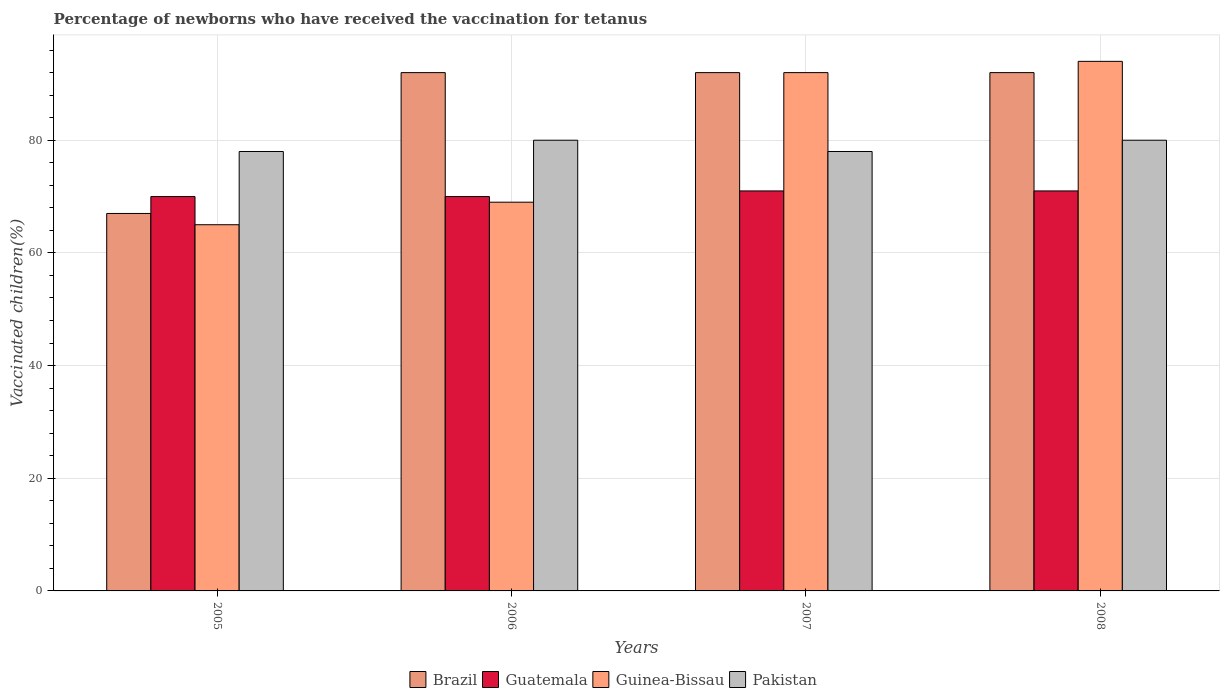How many different coloured bars are there?
Keep it short and to the point. 4. Are the number of bars on each tick of the X-axis equal?
Make the answer very short. Yes. How many bars are there on the 1st tick from the left?
Keep it short and to the point. 4. How many bars are there on the 2nd tick from the right?
Offer a terse response. 4. What is the percentage of vaccinated children in Guatemala in 2006?
Provide a succinct answer. 70. Across all years, what is the maximum percentage of vaccinated children in Guatemala?
Provide a succinct answer. 71. In which year was the percentage of vaccinated children in Guatemala maximum?
Provide a succinct answer. 2007. What is the total percentage of vaccinated children in Guatemala in the graph?
Provide a short and direct response. 282. What is the difference between the percentage of vaccinated children in Pakistan in 2005 and that in 2007?
Offer a terse response. 0. What is the average percentage of vaccinated children in Guinea-Bissau per year?
Keep it short and to the point. 80. What is the ratio of the percentage of vaccinated children in Guatemala in 2006 to that in 2008?
Your response must be concise. 0.99. Is the percentage of vaccinated children in Brazil in 2006 less than that in 2007?
Give a very brief answer. No. What is the difference between the highest and the second highest percentage of vaccinated children in Brazil?
Provide a succinct answer. 0. In how many years, is the percentage of vaccinated children in Guinea-Bissau greater than the average percentage of vaccinated children in Guinea-Bissau taken over all years?
Your response must be concise. 2. Is the sum of the percentage of vaccinated children in Pakistan in 2007 and 2008 greater than the maximum percentage of vaccinated children in Guinea-Bissau across all years?
Your response must be concise. Yes. Is it the case that in every year, the sum of the percentage of vaccinated children in Guinea-Bissau and percentage of vaccinated children in Guatemala is greater than the sum of percentage of vaccinated children in Brazil and percentage of vaccinated children in Pakistan?
Your answer should be compact. No. What does the 1st bar from the right in 2007 represents?
Offer a terse response. Pakistan. How many bars are there?
Your answer should be very brief. 16. How many years are there in the graph?
Offer a very short reply. 4. Does the graph contain any zero values?
Provide a succinct answer. No. Does the graph contain grids?
Provide a short and direct response. Yes. Where does the legend appear in the graph?
Offer a very short reply. Bottom center. How many legend labels are there?
Give a very brief answer. 4. What is the title of the graph?
Your answer should be compact. Percentage of newborns who have received the vaccination for tetanus. What is the label or title of the X-axis?
Your answer should be compact. Years. What is the label or title of the Y-axis?
Make the answer very short. Vaccinated children(%). What is the Vaccinated children(%) of Brazil in 2005?
Offer a very short reply. 67. What is the Vaccinated children(%) of Guinea-Bissau in 2005?
Your answer should be compact. 65. What is the Vaccinated children(%) in Brazil in 2006?
Provide a short and direct response. 92. What is the Vaccinated children(%) of Guinea-Bissau in 2006?
Ensure brevity in your answer.  69. What is the Vaccinated children(%) of Pakistan in 2006?
Your answer should be very brief. 80. What is the Vaccinated children(%) of Brazil in 2007?
Offer a very short reply. 92. What is the Vaccinated children(%) of Guinea-Bissau in 2007?
Provide a short and direct response. 92. What is the Vaccinated children(%) of Brazil in 2008?
Provide a succinct answer. 92. What is the Vaccinated children(%) of Guinea-Bissau in 2008?
Keep it short and to the point. 94. Across all years, what is the maximum Vaccinated children(%) in Brazil?
Offer a very short reply. 92. Across all years, what is the maximum Vaccinated children(%) of Guatemala?
Make the answer very short. 71. Across all years, what is the maximum Vaccinated children(%) in Guinea-Bissau?
Your answer should be compact. 94. Across all years, what is the maximum Vaccinated children(%) of Pakistan?
Make the answer very short. 80. Across all years, what is the minimum Vaccinated children(%) in Brazil?
Make the answer very short. 67. Across all years, what is the minimum Vaccinated children(%) of Guatemala?
Offer a very short reply. 70. What is the total Vaccinated children(%) in Brazil in the graph?
Give a very brief answer. 343. What is the total Vaccinated children(%) in Guatemala in the graph?
Your answer should be compact. 282. What is the total Vaccinated children(%) of Guinea-Bissau in the graph?
Make the answer very short. 320. What is the total Vaccinated children(%) of Pakistan in the graph?
Provide a succinct answer. 316. What is the difference between the Vaccinated children(%) in Guinea-Bissau in 2005 and that in 2006?
Your answer should be compact. -4. What is the difference between the Vaccinated children(%) in Pakistan in 2005 and that in 2006?
Offer a terse response. -2. What is the difference between the Vaccinated children(%) of Brazil in 2005 and that in 2007?
Offer a terse response. -25. What is the difference between the Vaccinated children(%) of Guatemala in 2005 and that in 2007?
Your answer should be compact. -1. What is the difference between the Vaccinated children(%) in Brazil in 2005 and that in 2008?
Offer a terse response. -25. What is the difference between the Vaccinated children(%) in Guatemala in 2005 and that in 2008?
Offer a terse response. -1. What is the difference between the Vaccinated children(%) of Guinea-Bissau in 2005 and that in 2008?
Offer a very short reply. -29. What is the difference between the Vaccinated children(%) of Guatemala in 2006 and that in 2007?
Make the answer very short. -1. What is the difference between the Vaccinated children(%) of Pakistan in 2006 and that in 2007?
Your response must be concise. 2. What is the difference between the Vaccinated children(%) of Guatemala in 2006 and that in 2008?
Provide a succinct answer. -1. What is the difference between the Vaccinated children(%) of Pakistan in 2006 and that in 2008?
Your answer should be very brief. 0. What is the difference between the Vaccinated children(%) of Brazil in 2007 and that in 2008?
Your answer should be very brief. 0. What is the difference between the Vaccinated children(%) of Guatemala in 2007 and that in 2008?
Offer a very short reply. 0. What is the difference between the Vaccinated children(%) of Guinea-Bissau in 2007 and that in 2008?
Your answer should be very brief. -2. What is the difference between the Vaccinated children(%) of Brazil in 2005 and the Vaccinated children(%) of Guinea-Bissau in 2006?
Provide a short and direct response. -2. What is the difference between the Vaccinated children(%) of Brazil in 2005 and the Vaccinated children(%) of Pakistan in 2007?
Offer a terse response. -11. What is the difference between the Vaccinated children(%) of Guatemala in 2005 and the Vaccinated children(%) of Guinea-Bissau in 2007?
Make the answer very short. -22. What is the difference between the Vaccinated children(%) in Guatemala in 2005 and the Vaccinated children(%) in Pakistan in 2007?
Provide a succinct answer. -8. What is the difference between the Vaccinated children(%) in Guinea-Bissau in 2005 and the Vaccinated children(%) in Pakistan in 2007?
Make the answer very short. -13. What is the difference between the Vaccinated children(%) in Brazil in 2005 and the Vaccinated children(%) in Guatemala in 2008?
Provide a short and direct response. -4. What is the difference between the Vaccinated children(%) of Brazil in 2005 and the Vaccinated children(%) of Pakistan in 2008?
Ensure brevity in your answer.  -13. What is the difference between the Vaccinated children(%) of Guatemala in 2005 and the Vaccinated children(%) of Guinea-Bissau in 2008?
Your answer should be compact. -24. What is the difference between the Vaccinated children(%) of Guatemala in 2005 and the Vaccinated children(%) of Pakistan in 2008?
Give a very brief answer. -10. What is the difference between the Vaccinated children(%) of Guinea-Bissau in 2005 and the Vaccinated children(%) of Pakistan in 2008?
Provide a short and direct response. -15. What is the difference between the Vaccinated children(%) in Brazil in 2006 and the Vaccinated children(%) in Guatemala in 2007?
Ensure brevity in your answer.  21. What is the difference between the Vaccinated children(%) in Brazil in 2006 and the Vaccinated children(%) in Guinea-Bissau in 2007?
Your answer should be compact. 0. What is the difference between the Vaccinated children(%) of Brazil in 2006 and the Vaccinated children(%) of Pakistan in 2007?
Keep it short and to the point. 14. What is the difference between the Vaccinated children(%) of Guatemala in 2006 and the Vaccinated children(%) of Pakistan in 2007?
Give a very brief answer. -8. What is the difference between the Vaccinated children(%) in Guinea-Bissau in 2006 and the Vaccinated children(%) in Pakistan in 2007?
Your response must be concise. -9. What is the difference between the Vaccinated children(%) of Brazil in 2006 and the Vaccinated children(%) of Guinea-Bissau in 2008?
Offer a very short reply. -2. What is the difference between the Vaccinated children(%) of Brazil in 2006 and the Vaccinated children(%) of Pakistan in 2008?
Your response must be concise. 12. What is the difference between the Vaccinated children(%) in Guatemala in 2006 and the Vaccinated children(%) in Pakistan in 2008?
Provide a short and direct response. -10. What is the difference between the Vaccinated children(%) of Brazil in 2007 and the Vaccinated children(%) of Guatemala in 2008?
Provide a succinct answer. 21. What is the difference between the Vaccinated children(%) of Guatemala in 2007 and the Vaccinated children(%) of Guinea-Bissau in 2008?
Keep it short and to the point. -23. What is the difference between the Vaccinated children(%) of Guatemala in 2007 and the Vaccinated children(%) of Pakistan in 2008?
Make the answer very short. -9. What is the average Vaccinated children(%) in Brazil per year?
Your response must be concise. 85.75. What is the average Vaccinated children(%) of Guatemala per year?
Make the answer very short. 70.5. What is the average Vaccinated children(%) of Pakistan per year?
Ensure brevity in your answer.  79. In the year 2005, what is the difference between the Vaccinated children(%) of Brazil and Vaccinated children(%) of Guatemala?
Give a very brief answer. -3. In the year 2005, what is the difference between the Vaccinated children(%) in Brazil and Vaccinated children(%) in Guinea-Bissau?
Offer a terse response. 2. In the year 2005, what is the difference between the Vaccinated children(%) of Guatemala and Vaccinated children(%) of Pakistan?
Keep it short and to the point. -8. In the year 2006, what is the difference between the Vaccinated children(%) in Brazil and Vaccinated children(%) in Guinea-Bissau?
Make the answer very short. 23. In the year 2006, what is the difference between the Vaccinated children(%) of Guatemala and Vaccinated children(%) of Guinea-Bissau?
Offer a terse response. 1. In the year 2006, what is the difference between the Vaccinated children(%) of Guatemala and Vaccinated children(%) of Pakistan?
Ensure brevity in your answer.  -10. In the year 2006, what is the difference between the Vaccinated children(%) in Guinea-Bissau and Vaccinated children(%) in Pakistan?
Provide a short and direct response. -11. In the year 2007, what is the difference between the Vaccinated children(%) in Brazil and Vaccinated children(%) in Pakistan?
Give a very brief answer. 14. In the year 2007, what is the difference between the Vaccinated children(%) of Guatemala and Vaccinated children(%) of Guinea-Bissau?
Your response must be concise. -21. In the year 2008, what is the difference between the Vaccinated children(%) of Guatemala and Vaccinated children(%) of Guinea-Bissau?
Your answer should be very brief. -23. What is the ratio of the Vaccinated children(%) of Brazil in 2005 to that in 2006?
Provide a short and direct response. 0.73. What is the ratio of the Vaccinated children(%) in Guatemala in 2005 to that in 2006?
Ensure brevity in your answer.  1. What is the ratio of the Vaccinated children(%) of Guinea-Bissau in 2005 to that in 2006?
Your response must be concise. 0.94. What is the ratio of the Vaccinated children(%) in Pakistan in 2005 to that in 2006?
Your answer should be very brief. 0.97. What is the ratio of the Vaccinated children(%) in Brazil in 2005 to that in 2007?
Provide a succinct answer. 0.73. What is the ratio of the Vaccinated children(%) of Guatemala in 2005 to that in 2007?
Give a very brief answer. 0.99. What is the ratio of the Vaccinated children(%) in Guinea-Bissau in 2005 to that in 2007?
Provide a short and direct response. 0.71. What is the ratio of the Vaccinated children(%) of Brazil in 2005 to that in 2008?
Keep it short and to the point. 0.73. What is the ratio of the Vaccinated children(%) in Guatemala in 2005 to that in 2008?
Keep it short and to the point. 0.99. What is the ratio of the Vaccinated children(%) of Guinea-Bissau in 2005 to that in 2008?
Offer a terse response. 0.69. What is the ratio of the Vaccinated children(%) in Brazil in 2006 to that in 2007?
Offer a very short reply. 1. What is the ratio of the Vaccinated children(%) in Guatemala in 2006 to that in 2007?
Offer a terse response. 0.99. What is the ratio of the Vaccinated children(%) of Pakistan in 2006 to that in 2007?
Give a very brief answer. 1.03. What is the ratio of the Vaccinated children(%) in Guatemala in 2006 to that in 2008?
Your response must be concise. 0.99. What is the ratio of the Vaccinated children(%) of Guinea-Bissau in 2006 to that in 2008?
Keep it short and to the point. 0.73. What is the ratio of the Vaccinated children(%) of Guatemala in 2007 to that in 2008?
Provide a short and direct response. 1. What is the ratio of the Vaccinated children(%) of Guinea-Bissau in 2007 to that in 2008?
Keep it short and to the point. 0.98. What is the difference between the highest and the lowest Vaccinated children(%) of Guatemala?
Your answer should be compact. 1. What is the difference between the highest and the lowest Vaccinated children(%) in Guinea-Bissau?
Keep it short and to the point. 29. 